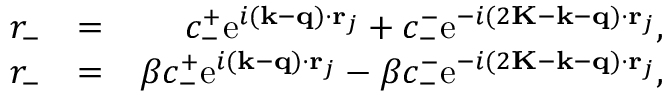Convert formula to latex. <formula><loc_0><loc_0><loc_500><loc_500>\begin{array} { r l r } { r _ { - } } & { = } & { c _ { - } ^ { + } e ^ { i ( k - q ) \cdot r _ { j } } + c _ { - } ^ { - } e ^ { - i ( 2 K - k - q ) \cdot r _ { j } } , } \\ { r _ { - } } & { = } & { \beta c _ { - } ^ { + } e ^ { i ( k - q ) \cdot r _ { j } } - \beta c _ { - } ^ { - } e ^ { - i ( 2 K - k - q ) \cdot r _ { j } } , } \end{array}</formula> 